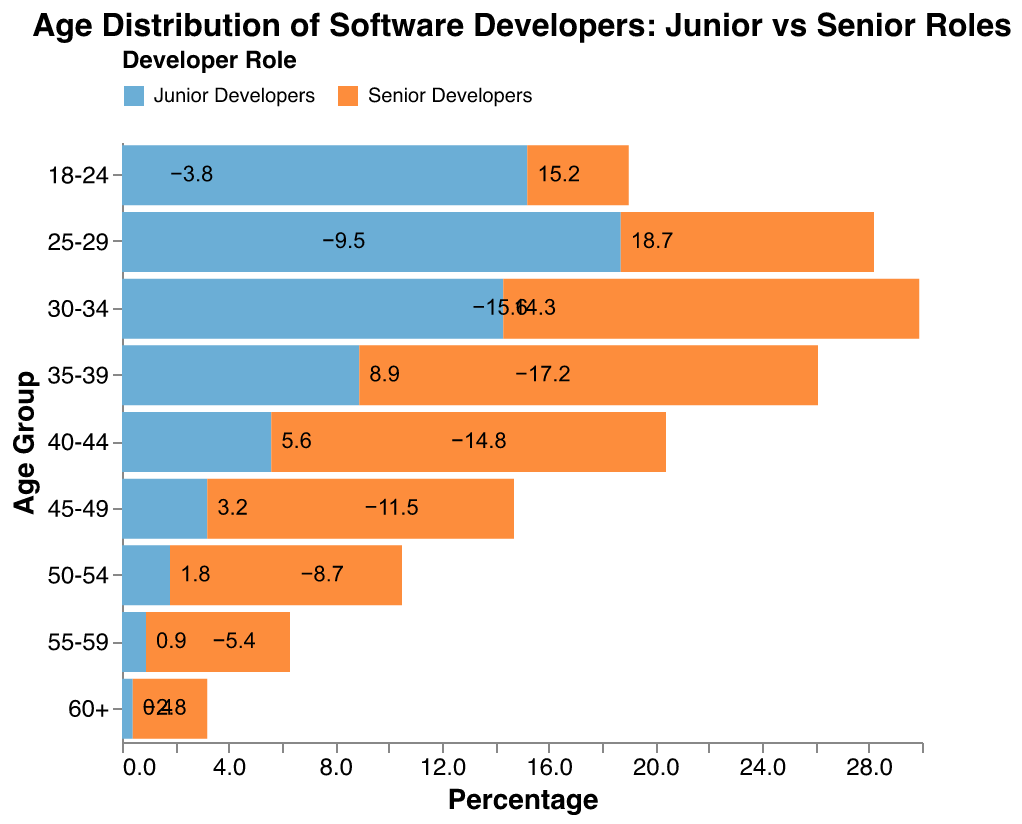What is the percentage of junior developers in the 18-24 age group? Look at the bar representing the 18-24 age group and find the height of the bar for junior developers. It shows 15.2%.
Answer: 15.2% Which age group has the highest percentage of senior developers? Identify the age group with the longest bar extending to the left for senior developers. The 35-39 age group has a value of -17.2%.
Answer: 35-39 What is the difference in percentage between junior and senior developers in the 30-34 age group? Find the values for both junior (14.3%) and senior (-15.6%) developers in the 30-34 age group. Calculate the difference: 14.3 - (-15.6) = 29.9%.
Answer: 29.9% At what age range do junior and senior developers’ percentages both drop below 10%? Look for the age groups where both junior and senior percentages fall below 10%. This first occurs in the 45-49 age group.
Answer: 45-49 What trend do you observe in the percentage of junior developers as age increases from 25 to 60+? Examine the bars for junior developers starting from the 25-29 age group up to 60+. The percentage steadily decreases from 18.7% to 0.4%.
Answer: Steady decrease How many age groups have more than a 10% difference between junior and senior developers? Calculate the difference for each age group by taking the absolute values, then count how many age groups have a difference greater than 10%. There are 5 such age groups: 25-29, 30-34, 35-39, 40-44, and 45-49.
Answer: 5 In which age group do junior developers outnumber senior developers the most? Compare the discrepancy between junior and senior developers across age groups, the largest difference can be found in 25-29: 18.7 - (-9.5) = 28.2%.
Answer: 25-29 What is the average percentage of senior developers across all age groups? Sum the percentages for senior developers: -3.8 - 9.5 - 15.6 - 17.2 - 14.8 - 11.5 - 8.7 - 5.4 - 2.8 = -88.3%. Divide by the number of age groups (9), so the average is -88.3 / 9 ≈ -9.8%.
Answer: -9.8% Are there any age groups where senior developers are equal or more than junior developers? Compare each age group’s junior and senior percentages. Since all senior developer values are negative and junior developer values are positive, there are no age groups where senior developers are equal or more than junior developers.
Answer: None How does the proportion of junior developers in the 40-44 age group compare to that in the 50-54 age group? Compare the percentages for both age groups: 40-44 for juniors is 5.6%, while 50-54 is 1.8%.
Answer: 5.6% vs. 1.8% 